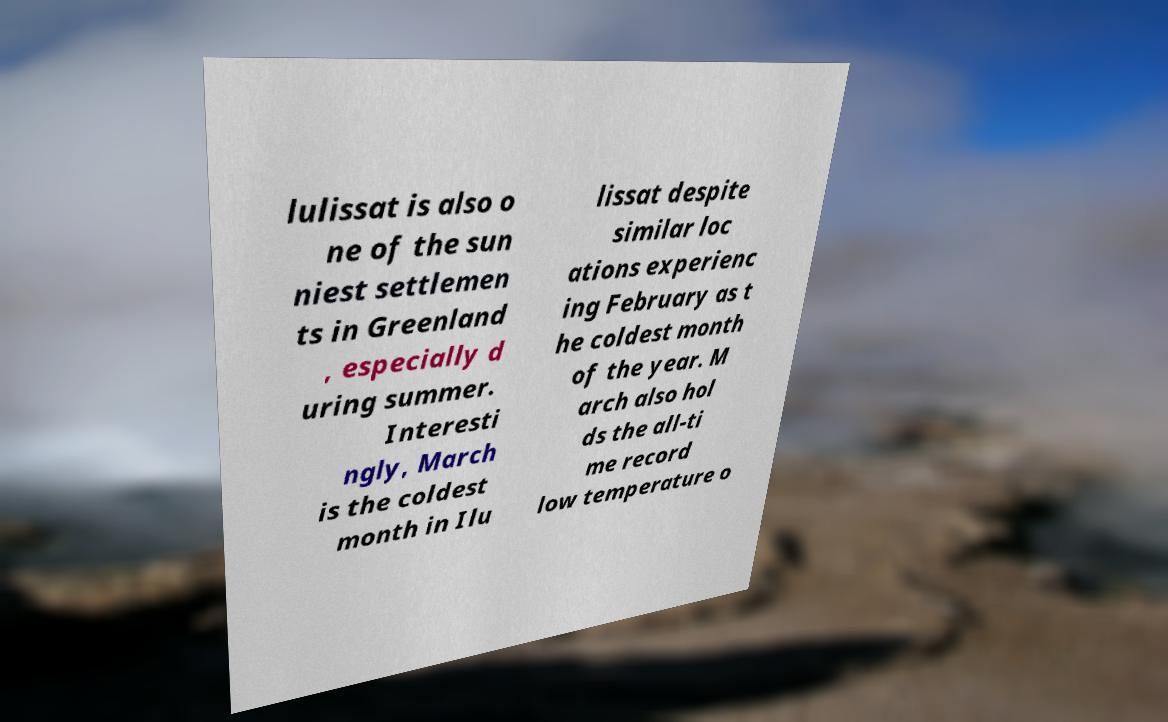Please identify and transcribe the text found in this image. lulissat is also o ne of the sun niest settlemen ts in Greenland , especially d uring summer. Interesti ngly, March is the coldest month in Ilu lissat despite similar loc ations experienc ing February as t he coldest month of the year. M arch also hol ds the all-ti me record low temperature o 